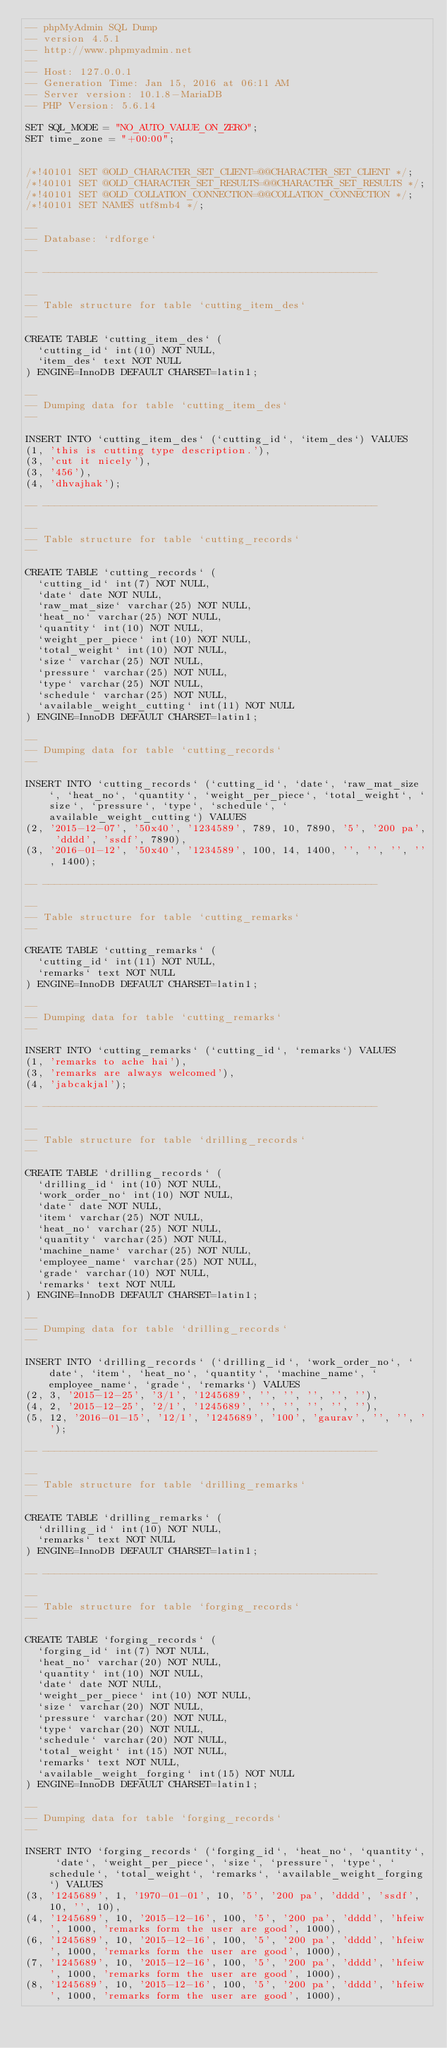<code> <loc_0><loc_0><loc_500><loc_500><_SQL_>-- phpMyAdmin SQL Dump
-- version 4.5.1
-- http://www.phpmyadmin.net
--
-- Host: 127.0.0.1
-- Generation Time: Jan 15, 2016 at 06:11 AM
-- Server version: 10.1.8-MariaDB
-- PHP Version: 5.6.14

SET SQL_MODE = "NO_AUTO_VALUE_ON_ZERO";
SET time_zone = "+00:00";


/*!40101 SET @OLD_CHARACTER_SET_CLIENT=@@CHARACTER_SET_CLIENT */;
/*!40101 SET @OLD_CHARACTER_SET_RESULTS=@@CHARACTER_SET_RESULTS */;
/*!40101 SET @OLD_COLLATION_CONNECTION=@@COLLATION_CONNECTION */;
/*!40101 SET NAMES utf8mb4 */;

--
-- Database: `rdforge`
--

-- --------------------------------------------------------

--
-- Table structure for table `cutting_item_des`
--

CREATE TABLE `cutting_item_des` (
  `cutting_id` int(10) NOT NULL,
  `item_des` text NOT NULL
) ENGINE=InnoDB DEFAULT CHARSET=latin1;

--
-- Dumping data for table `cutting_item_des`
--

INSERT INTO `cutting_item_des` (`cutting_id`, `item_des`) VALUES
(1, 'this is cutting type description.'),
(3, 'cut it nicely'),
(3, '456'),
(4, 'dhvajhak');

-- --------------------------------------------------------

--
-- Table structure for table `cutting_records`
--

CREATE TABLE `cutting_records` (
  `cutting_id` int(7) NOT NULL,
  `date` date NOT NULL,
  `raw_mat_size` varchar(25) NOT NULL,
  `heat_no` varchar(25) NOT NULL,
  `quantity` int(10) NOT NULL,
  `weight_per_piece` int(10) NOT NULL,
  `total_weight` int(10) NOT NULL,
  `size` varchar(25) NOT NULL,
  `pressure` varchar(25) NOT NULL,
  `type` varchar(25) NOT NULL,
  `schedule` varchar(25) NOT NULL,
  `available_weight_cutting` int(11) NOT NULL
) ENGINE=InnoDB DEFAULT CHARSET=latin1;

--
-- Dumping data for table `cutting_records`
--

INSERT INTO `cutting_records` (`cutting_id`, `date`, `raw_mat_size`, `heat_no`, `quantity`, `weight_per_piece`, `total_weight`, `size`, `pressure`, `type`, `schedule`, `available_weight_cutting`) VALUES
(2, '2015-12-07', '50x40', '1234589', 789, 10, 7890, '5', '200 pa', 'dddd', 'ssdf', 7890),
(3, '2016-01-12', '50x40', '1234589', 100, 14, 1400, '', '', '', '', 1400);

-- --------------------------------------------------------

--
-- Table structure for table `cutting_remarks`
--

CREATE TABLE `cutting_remarks` (
  `cutting_id` int(11) NOT NULL,
  `remarks` text NOT NULL
) ENGINE=InnoDB DEFAULT CHARSET=latin1;

--
-- Dumping data for table `cutting_remarks`
--

INSERT INTO `cutting_remarks` (`cutting_id`, `remarks`) VALUES
(1, 'remarks to ache hai'),
(3, 'remarks are always welcomed'),
(4, 'jabcakjal');

-- --------------------------------------------------------

--
-- Table structure for table `drilling_records`
--

CREATE TABLE `drilling_records` (
  `drilling_id` int(10) NOT NULL,
  `work_order_no` int(10) NOT NULL,
  `date` date NOT NULL,
  `item` varchar(25) NOT NULL,
  `heat_no` varchar(25) NOT NULL,
  `quantity` varchar(25) NOT NULL,
  `machine_name` varchar(25) NOT NULL,
  `employee_name` varchar(25) NOT NULL,
  `grade` varchar(10) NOT NULL,
  `remarks` text NOT NULL
) ENGINE=InnoDB DEFAULT CHARSET=latin1;

--
-- Dumping data for table `drilling_records`
--

INSERT INTO `drilling_records` (`drilling_id`, `work_order_no`, `date`, `item`, `heat_no`, `quantity`, `machine_name`, `employee_name`, `grade`, `remarks`) VALUES
(2, 3, '2015-12-25', '3/1', '1245689', '', '', '', '', ''),
(4, 2, '2015-12-25', '2/1', '1245689', '', '', '', '', ''),
(5, 12, '2016-01-15', '12/1', '1245689', '100', 'gaurav', '', '', '');

-- --------------------------------------------------------

--
-- Table structure for table `drilling_remarks`
--

CREATE TABLE `drilling_remarks` (
  `drilling_id` int(10) NOT NULL,
  `remarks` text NOT NULL
) ENGINE=InnoDB DEFAULT CHARSET=latin1;

-- --------------------------------------------------------

--
-- Table structure for table `forging_records`
--

CREATE TABLE `forging_records` (
  `forging_id` int(7) NOT NULL,
  `heat_no` varchar(20) NOT NULL,
  `quantity` int(10) NOT NULL,
  `date` date NOT NULL,
  `weight_per_piece` int(10) NOT NULL,
  `size` varchar(20) NOT NULL,
  `pressure` varchar(20) NOT NULL,
  `type` varchar(20) NOT NULL,
  `schedule` varchar(20) NOT NULL,
  `total_weight` int(15) NOT NULL,
  `remarks` text NOT NULL,
  `available_weight_forging` int(15) NOT NULL
) ENGINE=InnoDB DEFAULT CHARSET=latin1;

--
-- Dumping data for table `forging_records`
--

INSERT INTO `forging_records` (`forging_id`, `heat_no`, `quantity`, `date`, `weight_per_piece`, `size`, `pressure`, `type`, `schedule`, `total_weight`, `remarks`, `available_weight_forging`) VALUES
(3, '1245689', 1, '1970-01-01', 10, '5', '200 pa', 'dddd', 'ssdf', 10, '', 10),
(4, '1245689', 10, '2015-12-16', 100, '5', '200 pa', 'dddd', 'hfeiw', 1000, 'remarks form the user are good', 1000),
(6, '1245689', 10, '2015-12-16', 100, '5', '200 pa', 'dddd', 'hfeiw', 1000, 'remarks form the user are good', 1000),
(7, '1245689', 10, '2015-12-16', 100, '5', '200 pa', 'dddd', 'hfeiw', 1000, 'remarks form the user are good', 1000),
(8, '1245689', 10, '2015-12-16', 100, '5', '200 pa', 'dddd', 'hfeiw', 1000, 'remarks form the user are good', 1000),</code> 